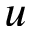Convert formula to latex. <formula><loc_0><loc_0><loc_500><loc_500>u</formula> 